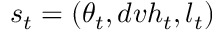<formula> <loc_0><loc_0><loc_500><loc_500>s _ { t } = ( \theta _ { t } , d v h _ { t } , l _ { t } )</formula> 